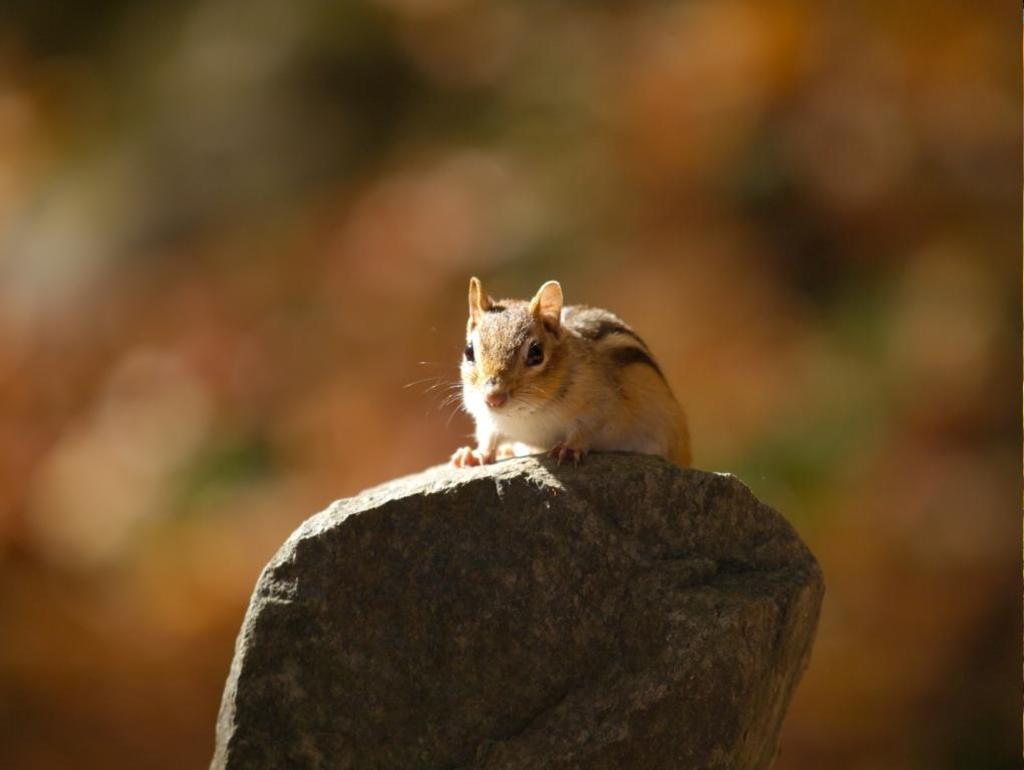What is the main subject in the middle of the image? There is a stone in the middle of the image. What is on top of the stone? There is a squirrel on the stone. Can you describe the background of the image? The background of the image is blurred. What type of box is the squirrel using to stretch its legs in the image? There is no box present in the image, and the squirrel is not stretching its legs. 